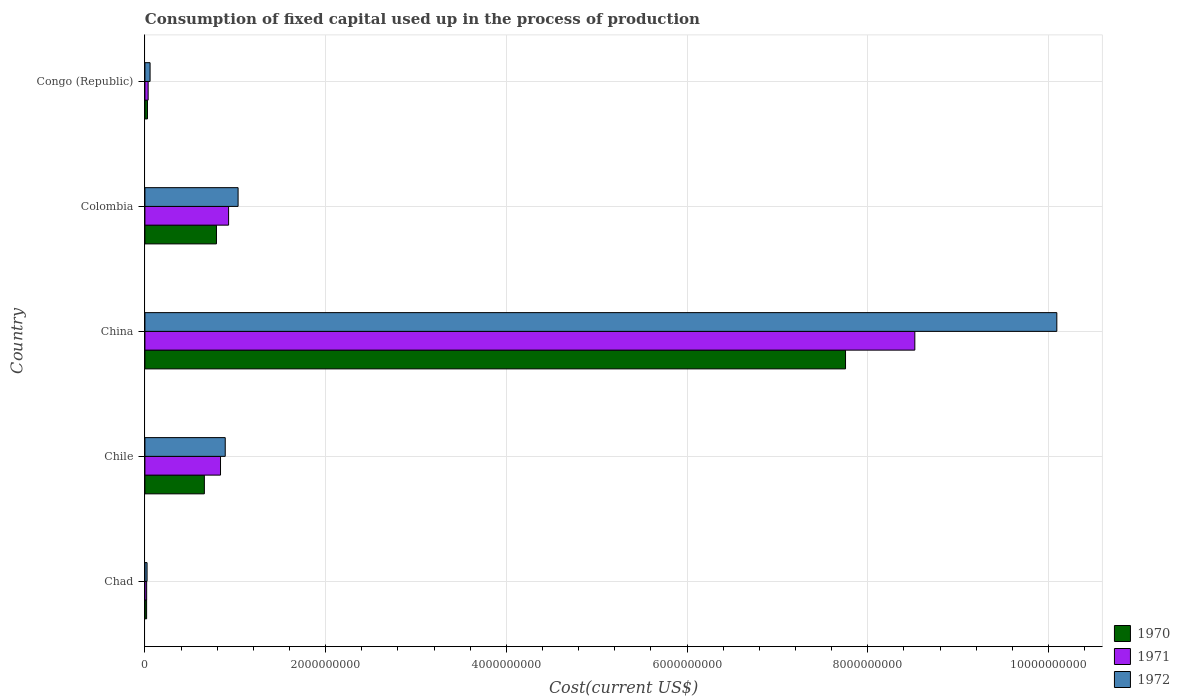Are the number of bars per tick equal to the number of legend labels?
Ensure brevity in your answer.  Yes. Are the number of bars on each tick of the Y-axis equal?
Your answer should be very brief. Yes. How many bars are there on the 2nd tick from the top?
Ensure brevity in your answer.  3. What is the amount consumed in the process of production in 1971 in Chad?
Provide a short and direct response. 1.92e+07. Across all countries, what is the maximum amount consumed in the process of production in 1971?
Offer a terse response. 8.52e+09. Across all countries, what is the minimum amount consumed in the process of production in 1970?
Keep it short and to the point. 1.87e+07. In which country was the amount consumed in the process of production in 1972 maximum?
Keep it short and to the point. China. In which country was the amount consumed in the process of production in 1970 minimum?
Your answer should be compact. Chad. What is the total amount consumed in the process of production in 1971 in the graph?
Ensure brevity in your answer.  1.03e+1. What is the difference between the amount consumed in the process of production in 1970 in Chile and that in China?
Your answer should be compact. -7.10e+09. What is the difference between the amount consumed in the process of production in 1972 in Chile and the amount consumed in the process of production in 1970 in Colombia?
Keep it short and to the point. 9.71e+07. What is the average amount consumed in the process of production in 1972 per country?
Give a very brief answer. 2.42e+09. What is the difference between the amount consumed in the process of production in 1970 and amount consumed in the process of production in 1971 in Chile?
Your answer should be compact. -1.79e+08. What is the ratio of the amount consumed in the process of production in 1972 in Chad to that in China?
Give a very brief answer. 0. Is the amount consumed in the process of production in 1972 in Chile less than that in Congo (Republic)?
Provide a succinct answer. No. Is the difference between the amount consumed in the process of production in 1970 in Chad and Congo (Republic) greater than the difference between the amount consumed in the process of production in 1971 in Chad and Congo (Republic)?
Offer a terse response. Yes. What is the difference between the highest and the second highest amount consumed in the process of production in 1972?
Keep it short and to the point. 9.06e+09. What is the difference between the highest and the lowest amount consumed in the process of production in 1971?
Give a very brief answer. 8.50e+09. In how many countries, is the amount consumed in the process of production in 1972 greater than the average amount consumed in the process of production in 1972 taken over all countries?
Your answer should be compact. 1. What does the 1st bar from the top in Congo (Republic) represents?
Ensure brevity in your answer.  1972. What does the 3rd bar from the bottom in Congo (Republic) represents?
Your answer should be compact. 1972. Is it the case that in every country, the sum of the amount consumed in the process of production in 1971 and amount consumed in the process of production in 1970 is greater than the amount consumed in the process of production in 1972?
Give a very brief answer. Yes. How many countries are there in the graph?
Provide a succinct answer. 5. What is the difference between two consecutive major ticks on the X-axis?
Offer a terse response. 2.00e+09. Where does the legend appear in the graph?
Keep it short and to the point. Bottom right. What is the title of the graph?
Ensure brevity in your answer.  Consumption of fixed capital used up in the process of production. Does "2012" appear as one of the legend labels in the graph?
Offer a very short reply. No. What is the label or title of the X-axis?
Give a very brief answer. Cost(current US$). What is the Cost(current US$) in 1970 in Chad?
Keep it short and to the point. 1.87e+07. What is the Cost(current US$) in 1971 in Chad?
Make the answer very short. 1.92e+07. What is the Cost(current US$) of 1972 in Chad?
Ensure brevity in your answer.  2.37e+07. What is the Cost(current US$) in 1970 in Chile?
Give a very brief answer. 6.58e+08. What is the Cost(current US$) in 1971 in Chile?
Give a very brief answer. 8.37e+08. What is the Cost(current US$) of 1972 in Chile?
Make the answer very short. 8.89e+08. What is the Cost(current US$) of 1970 in China?
Your answer should be very brief. 7.75e+09. What is the Cost(current US$) of 1971 in China?
Your answer should be very brief. 8.52e+09. What is the Cost(current US$) in 1972 in China?
Your answer should be compact. 1.01e+1. What is the Cost(current US$) of 1970 in Colombia?
Keep it short and to the point. 7.92e+08. What is the Cost(current US$) of 1971 in Colombia?
Your answer should be compact. 9.26e+08. What is the Cost(current US$) of 1972 in Colombia?
Your response must be concise. 1.03e+09. What is the Cost(current US$) of 1970 in Congo (Republic)?
Make the answer very short. 2.83e+07. What is the Cost(current US$) in 1971 in Congo (Republic)?
Your response must be concise. 3.57e+07. What is the Cost(current US$) in 1972 in Congo (Republic)?
Provide a succinct answer. 5.71e+07. Across all countries, what is the maximum Cost(current US$) of 1970?
Provide a short and direct response. 7.75e+09. Across all countries, what is the maximum Cost(current US$) of 1971?
Give a very brief answer. 8.52e+09. Across all countries, what is the maximum Cost(current US$) in 1972?
Keep it short and to the point. 1.01e+1. Across all countries, what is the minimum Cost(current US$) of 1970?
Offer a very short reply. 1.87e+07. Across all countries, what is the minimum Cost(current US$) of 1971?
Ensure brevity in your answer.  1.92e+07. Across all countries, what is the minimum Cost(current US$) in 1972?
Keep it short and to the point. 2.37e+07. What is the total Cost(current US$) of 1970 in the graph?
Provide a short and direct response. 9.25e+09. What is the total Cost(current US$) of 1971 in the graph?
Offer a very short reply. 1.03e+1. What is the total Cost(current US$) of 1972 in the graph?
Provide a succinct answer. 1.21e+1. What is the difference between the Cost(current US$) of 1970 in Chad and that in Chile?
Ensure brevity in your answer.  -6.39e+08. What is the difference between the Cost(current US$) in 1971 in Chad and that in Chile?
Provide a short and direct response. -8.17e+08. What is the difference between the Cost(current US$) of 1972 in Chad and that in Chile?
Offer a very short reply. -8.65e+08. What is the difference between the Cost(current US$) in 1970 in Chad and that in China?
Offer a terse response. -7.74e+09. What is the difference between the Cost(current US$) of 1971 in Chad and that in China?
Your answer should be very brief. -8.50e+09. What is the difference between the Cost(current US$) of 1972 in Chad and that in China?
Ensure brevity in your answer.  -1.01e+1. What is the difference between the Cost(current US$) in 1970 in Chad and that in Colombia?
Ensure brevity in your answer.  -7.73e+08. What is the difference between the Cost(current US$) of 1971 in Chad and that in Colombia?
Provide a succinct answer. -9.07e+08. What is the difference between the Cost(current US$) in 1972 in Chad and that in Colombia?
Provide a short and direct response. -1.01e+09. What is the difference between the Cost(current US$) of 1970 in Chad and that in Congo (Republic)?
Your response must be concise. -9.59e+06. What is the difference between the Cost(current US$) of 1971 in Chad and that in Congo (Republic)?
Keep it short and to the point. -1.65e+07. What is the difference between the Cost(current US$) in 1972 in Chad and that in Congo (Republic)?
Offer a terse response. -3.35e+07. What is the difference between the Cost(current US$) of 1970 in Chile and that in China?
Give a very brief answer. -7.10e+09. What is the difference between the Cost(current US$) in 1971 in Chile and that in China?
Provide a succinct answer. -7.68e+09. What is the difference between the Cost(current US$) of 1972 in Chile and that in China?
Offer a very short reply. -9.20e+09. What is the difference between the Cost(current US$) of 1970 in Chile and that in Colombia?
Keep it short and to the point. -1.34e+08. What is the difference between the Cost(current US$) of 1971 in Chile and that in Colombia?
Provide a short and direct response. -8.94e+07. What is the difference between the Cost(current US$) in 1972 in Chile and that in Colombia?
Your answer should be compact. -1.42e+08. What is the difference between the Cost(current US$) in 1970 in Chile and that in Congo (Republic)?
Your response must be concise. 6.30e+08. What is the difference between the Cost(current US$) of 1971 in Chile and that in Congo (Republic)?
Keep it short and to the point. 8.01e+08. What is the difference between the Cost(current US$) of 1972 in Chile and that in Congo (Republic)?
Make the answer very short. 8.32e+08. What is the difference between the Cost(current US$) of 1970 in China and that in Colombia?
Provide a short and direct response. 6.96e+09. What is the difference between the Cost(current US$) of 1971 in China and that in Colombia?
Your answer should be very brief. 7.60e+09. What is the difference between the Cost(current US$) of 1972 in China and that in Colombia?
Provide a short and direct response. 9.06e+09. What is the difference between the Cost(current US$) in 1970 in China and that in Congo (Republic)?
Offer a terse response. 7.73e+09. What is the difference between the Cost(current US$) of 1971 in China and that in Congo (Republic)?
Provide a short and direct response. 8.49e+09. What is the difference between the Cost(current US$) in 1972 in China and that in Congo (Republic)?
Your answer should be very brief. 1.00e+1. What is the difference between the Cost(current US$) of 1970 in Colombia and that in Congo (Republic)?
Ensure brevity in your answer.  7.64e+08. What is the difference between the Cost(current US$) of 1971 in Colombia and that in Congo (Republic)?
Your response must be concise. 8.90e+08. What is the difference between the Cost(current US$) of 1972 in Colombia and that in Congo (Republic)?
Your answer should be very brief. 9.74e+08. What is the difference between the Cost(current US$) in 1970 in Chad and the Cost(current US$) in 1971 in Chile?
Offer a terse response. -8.18e+08. What is the difference between the Cost(current US$) in 1970 in Chad and the Cost(current US$) in 1972 in Chile?
Your answer should be compact. -8.70e+08. What is the difference between the Cost(current US$) of 1971 in Chad and the Cost(current US$) of 1972 in Chile?
Provide a short and direct response. -8.70e+08. What is the difference between the Cost(current US$) in 1970 in Chad and the Cost(current US$) in 1971 in China?
Provide a short and direct response. -8.50e+09. What is the difference between the Cost(current US$) of 1970 in Chad and the Cost(current US$) of 1972 in China?
Your answer should be compact. -1.01e+1. What is the difference between the Cost(current US$) in 1971 in Chad and the Cost(current US$) in 1972 in China?
Keep it short and to the point. -1.01e+1. What is the difference between the Cost(current US$) of 1970 in Chad and the Cost(current US$) of 1971 in Colombia?
Make the answer very short. -9.07e+08. What is the difference between the Cost(current US$) of 1970 in Chad and the Cost(current US$) of 1972 in Colombia?
Keep it short and to the point. -1.01e+09. What is the difference between the Cost(current US$) in 1971 in Chad and the Cost(current US$) in 1972 in Colombia?
Ensure brevity in your answer.  -1.01e+09. What is the difference between the Cost(current US$) of 1970 in Chad and the Cost(current US$) of 1971 in Congo (Republic)?
Provide a short and direct response. -1.70e+07. What is the difference between the Cost(current US$) of 1970 in Chad and the Cost(current US$) of 1972 in Congo (Republic)?
Keep it short and to the point. -3.85e+07. What is the difference between the Cost(current US$) of 1971 in Chad and the Cost(current US$) of 1972 in Congo (Republic)?
Provide a succinct answer. -3.80e+07. What is the difference between the Cost(current US$) of 1970 in Chile and the Cost(current US$) of 1971 in China?
Your answer should be compact. -7.86e+09. What is the difference between the Cost(current US$) of 1970 in Chile and the Cost(current US$) of 1972 in China?
Offer a terse response. -9.44e+09. What is the difference between the Cost(current US$) in 1971 in Chile and the Cost(current US$) in 1972 in China?
Your response must be concise. -9.26e+09. What is the difference between the Cost(current US$) of 1970 in Chile and the Cost(current US$) of 1971 in Colombia?
Your answer should be very brief. -2.68e+08. What is the difference between the Cost(current US$) of 1970 in Chile and the Cost(current US$) of 1972 in Colombia?
Make the answer very short. -3.73e+08. What is the difference between the Cost(current US$) in 1971 in Chile and the Cost(current US$) in 1972 in Colombia?
Make the answer very short. -1.95e+08. What is the difference between the Cost(current US$) of 1970 in Chile and the Cost(current US$) of 1971 in Congo (Republic)?
Offer a very short reply. 6.22e+08. What is the difference between the Cost(current US$) of 1970 in Chile and the Cost(current US$) of 1972 in Congo (Republic)?
Ensure brevity in your answer.  6.01e+08. What is the difference between the Cost(current US$) in 1971 in Chile and the Cost(current US$) in 1972 in Congo (Republic)?
Keep it short and to the point. 7.79e+08. What is the difference between the Cost(current US$) of 1970 in China and the Cost(current US$) of 1971 in Colombia?
Give a very brief answer. 6.83e+09. What is the difference between the Cost(current US$) of 1970 in China and the Cost(current US$) of 1972 in Colombia?
Offer a terse response. 6.72e+09. What is the difference between the Cost(current US$) of 1971 in China and the Cost(current US$) of 1972 in Colombia?
Your answer should be compact. 7.49e+09. What is the difference between the Cost(current US$) of 1970 in China and the Cost(current US$) of 1971 in Congo (Republic)?
Your response must be concise. 7.72e+09. What is the difference between the Cost(current US$) in 1970 in China and the Cost(current US$) in 1972 in Congo (Republic)?
Your response must be concise. 7.70e+09. What is the difference between the Cost(current US$) in 1971 in China and the Cost(current US$) in 1972 in Congo (Republic)?
Your response must be concise. 8.46e+09. What is the difference between the Cost(current US$) in 1970 in Colombia and the Cost(current US$) in 1971 in Congo (Republic)?
Provide a short and direct response. 7.56e+08. What is the difference between the Cost(current US$) of 1970 in Colombia and the Cost(current US$) of 1972 in Congo (Republic)?
Keep it short and to the point. 7.35e+08. What is the difference between the Cost(current US$) in 1971 in Colombia and the Cost(current US$) in 1972 in Congo (Republic)?
Your response must be concise. 8.69e+08. What is the average Cost(current US$) of 1970 per country?
Your answer should be very brief. 1.85e+09. What is the average Cost(current US$) of 1971 per country?
Keep it short and to the point. 2.07e+09. What is the average Cost(current US$) in 1972 per country?
Your answer should be very brief. 2.42e+09. What is the difference between the Cost(current US$) in 1970 and Cost(current US$) in 1971 in Chad?
Your answer should be very brief. -4.79e+05. What is the difference between the Cost(current US$) of 1970 and Cost(current US$) of 1972 in Chad?
Your response must be concise. -4.98e+06. What is the difference between the Cost(current US$) in 1971 and Cost(current US$) in 1972 in Chad?
Keep it short and to the point. -4.50e+06. What is the difference between the Cost(current US$) of 1970 and Cost(current US$) of 1971 in Chile?
Offer a very short reply. -1.79e+08. What is the difference between the Cost(current US$) of 1970 and Cost(current US$) of 1972 in Chile?
Your answer should be very brief. -2.31e+08. What is the difference between the Cost(current US$) of 1971 and Cost(current US$) of 1972 in Chile?
Ensure brevity in your answer.  -5.24e+07. What is the difference between the Cost(current US$) in 1970 and Cost(current US$) in 1971 in China?
Your answer should be very brief. -7.67e+08. What is the difference between the Cost(current US$) in 1970 and Cost(current US$) in 1972 in China?
Offer a terse response. -2.34e+09. What is the difference between the Cost(current US$) in 1971 and Cost(current US$) in 1972 in China?
Your response must be concise. -1.57e+09. What is the difference between the Cost(current US$) of 1970 and Cost(current US$) of 1971 in Colombia?
Your answer should be very brief. -1.34e+08. What is the difference between the Cost(current US$) in 1970 and Cost(current US$) in 1972 in Colombia?
Ensure brevity in your answer.  -2.39e+08. What is the difference between the Cost(current US$) in 1971 and Cost(current US$) in 1972 in Colombia?
Your answer should be very brief. -1.05e+08. What is the difference between the Cost(current US$) in 1970 and Cost(current US$) in 1971 in Congo (Republic)?
Make the answer very short. -7.38e+06. What is the difference between the Cost(current US$) of 1970 and Cost(current US$) of 1972 in Congo (Republic)?
Give a very brief answer. -2.89e+07. What is the difference between the Cost(current US$) of 1971 and Cost(current US$) of 1972 in Congo (Republic)?
Your answer should be compact. -2.15e+07. What is the ratio of the Cost(current US$) in 1970 in Chad to that in Chile?
Your response must be concise. 0.03. What is the ratio of the Cost(current US$) of 1971 in Chad to that in Chile?
Ensure brevity in your answer.  0.02. What is the ratio of the Cost(current US$) of 1972 in Chad to that in Chile?
Your answer should be very brief. 0.03. What is the ratio of the Cost(current US$) in 1970 in Chad to that in China?
Provide a succinct answer. 0. What is the ratio of the Cost(current US$) in 1971 in Chad to that in China?
Provide a short and direct response. 0. What is the ratio of the Cost(current US$) in 1972 in Chad to that in China?
Ensure brevity in your answer.  0. What is the ratio of the Cost(current US$) of 1970 in Chad to that in Colombia?
Offer a very short reply. 0.02. What is the ratio of the Cost(current US$) of 1971 in Chad to that in Colombia?
Provide a short and direct response. 0.02. What is the ratio of the Cost(current US$) of 1972 in Chad to that in Colombia?
Your answer should be very brief. 0.02. What is the ratio of the Cost(current US$) of 1970 in Chad to that in Congo (Republic)?
Offer a very short reply. 0.66. What is the ratio of the Cost(current US$) in 1971 in Chad to that in Congo (Republic)?
Ensure brevity in your answer.  0.54. What is the ratio of the Cost(current US$) in 1972 in Chad to that in Congo (Republic)?
Offer a terse response. 0.41. What is the ratio of the Cost(current US$) in 1970 in Chile to that in China?
Your answer should be compact. 0.08. What is the ratio of the Cost(current US$) of 1971 in Chile to that in China?
Provide a succinct answer. 0.1. What is the ratio of the Cost(current US$) of 1972 in Chile to that in China?
Your answer should be very brief. 0.09. What is the ratio of the Cost(current US$) of 1970 in Chile to that in Colombia?
Your response must be concise. 0.83. What is the ratio of the Cost(current US$) in 1971 in Chile to that in Colombia?
Give a very brief answer. 0.9. What is the ratio of the Cost(current US$) in 1972 in Chile to that in Colombia?
Offer a very short reply. 0.86. What is the ratio of the Cost(current US$) in 1970 in Chile to that in Congo (Republic)?
Your answer should be compact. 23.26. What is the ratio of the Cost(current US$) in 1971 in Chile to that in Congo (Republic)?
Offer a very short reply. 23.46. What is the ratio of the Cost(current US$) of 1972 in Chile to that in Congo (Republic)?
Your answer should be very brief. 15.56. What is the ratio of the Cost(current US$) of 1970 in China to that in Colombia?
Provide a succinct answer. 9.79. What is the ratio of the Cost(current US$) in 1971 in China to that in Colombia?
Keep it short and to the point. 9.2. What is the ratio of the Cost(current US$) of 1972 in China to that in Colombia?
Your answer should be compact. 9.79. What is the ratio of the Cost(current US$) of 1970 in China to that in Congo (Republic)?
Your answer should be very brief. 274.16. What is the ratio of the Cost(current US$) of 1971 in China to that in Congo (Republic)?
Offer a very short reply. 238.93. What is the ratio of the Cost(current US$) of 1972 in China to that in Congo (Republic)?
Offer a terse response. 176.62. What is the ratio of the Cost(current US$) of 1970 in Colombia to that in Congo (Republic)?
Offer a very short reply. 28. What is the ratio of the Cost(current US$) of 1971 in Colombia to that in Congo (Republic)?
Your response must be concise. 25.97. What is the ratio of the Cost(current US$) of 1972 in Colombia to that in Congo (Republic)?
Your response must be concise. 18.05. What is the difference between the highest and the second highest Cost(current US$) in 1970?
Ensure brevity in your answer.  6.96e+09. What is the difference between the highest and the second highest Cost(current US$) of 1971?
Make the answer very short. 7.60e+09. What is the difference between the highest and the second highest Cost(current US$) in 1972?
Ensure brevity in your answer.  9.06e+09. What is the difference between the highest and the lowest Cost(current US$) in 1970?
Offer a very short reply. 7.74e+09. What is the difference between the highest and the lowest Cost(current US$) of 1971?
Keep it short and to the point. 8.50e+09. What is the difference between the highest and the lowest Cost(current US$) in 1972?
Provide a succinct answer. 1.01e+1. 